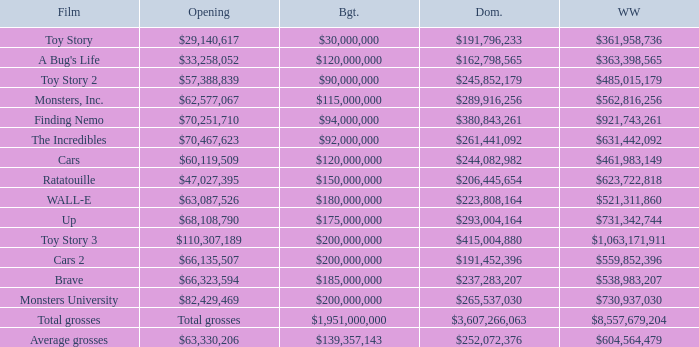WHAT IS THE BUDGET FOR THE INCREDIBLES? $92,000,000. 